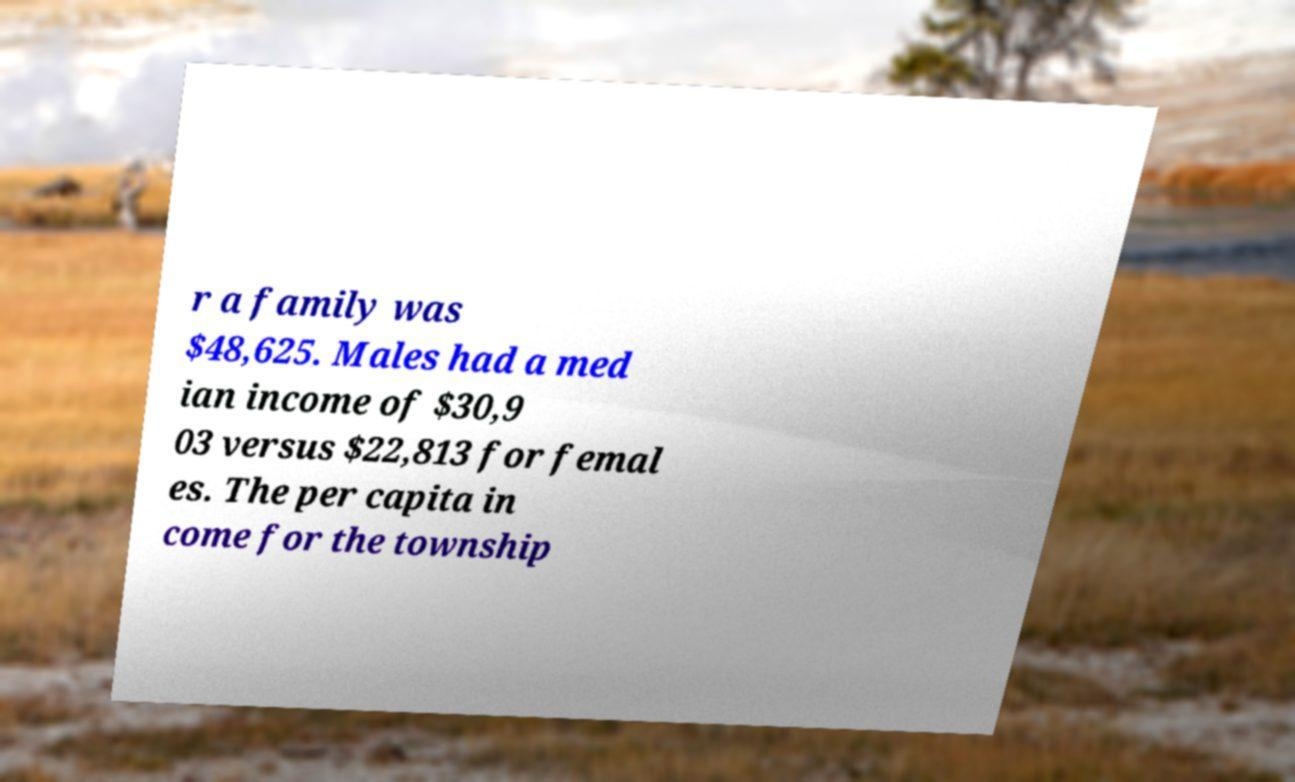I need the written content from this picture converted into text. Can you do that? r a family was $48,625. Males had a med ian income of $30,9 03 versus $22,813 for femal es. The per capita in come for the township 